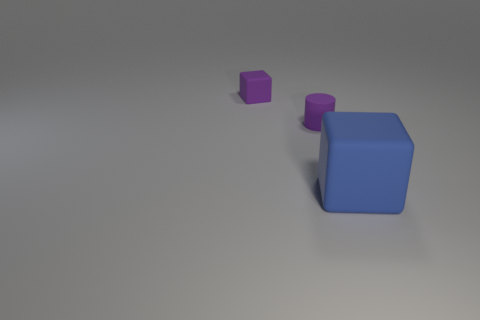Add 2 small cylinders. How many objects exist? 5 Subtract all cylinders. How many objects are left? 2 Add 1 small matte cylinders. How many small matte cylinders exist? 2 Subtract 0 red cylinders. How many objects are left? 3 Subtract all tiny matte blocks. Subtract all tiny purple matte cylinders. How many objects are left? 1 Add 1 purple cylinders. How many purple cylinders are left? 2 